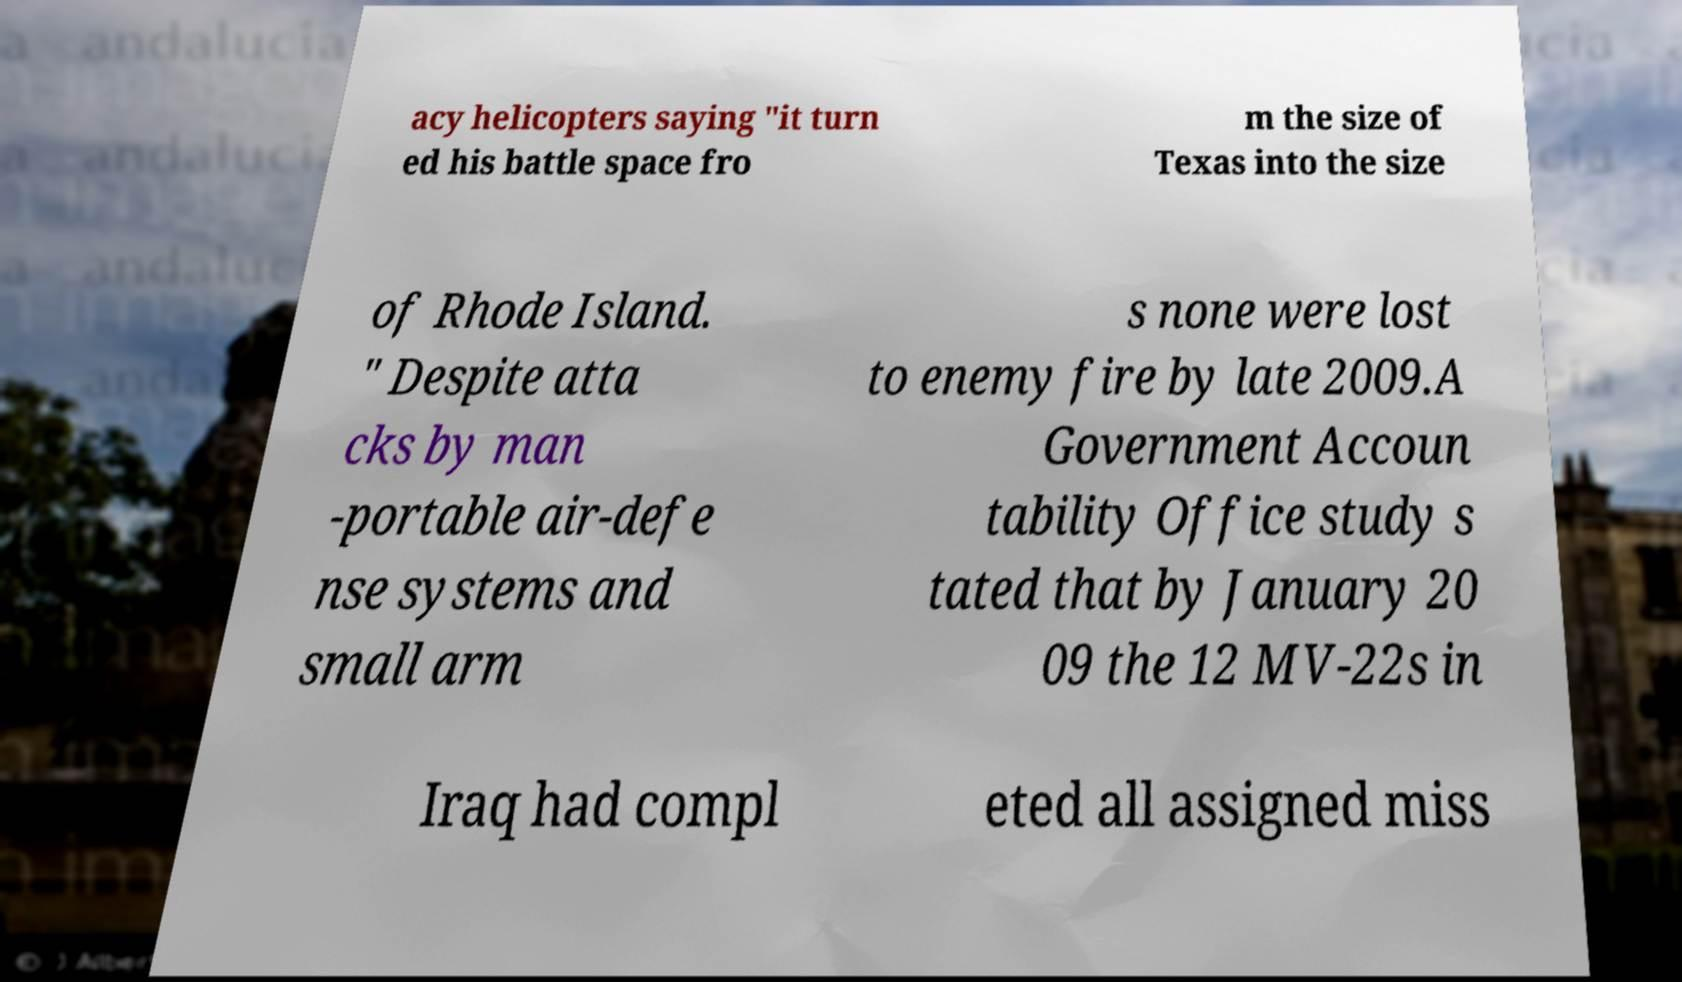For documentation purposes, I need the text within this image transcribed. Could you provide that? acy helicopters saying "it turn ed his battle space fro m the size of Texas into the size of Rhode Island. " Despite atta cks by man -portable air-defe nse systems and small arm s none were lost to enemy fire by late 2009.A Government Accoun tability Office study s tated that by January 20 09 the 12 MV-22s in Iraq had compl eted all assigned miss 